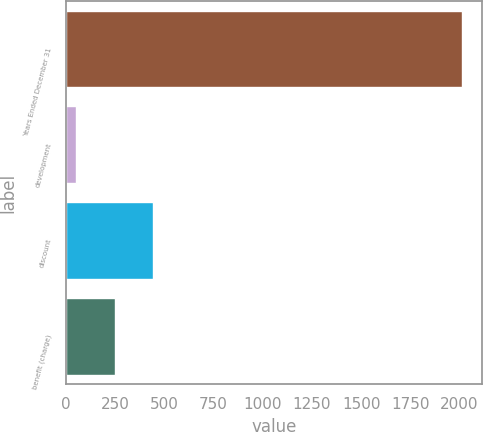Convert chart to OTSL. <chart><loc_0><loc_0><loc_500><loc_500><bar_chart><fcel>Years Ended December 31<fcel>development<fcel>discount<fcel>benefit (charge)<nl><fcel>2014<fcel>52<fcel>444.4<fcel>248.2<nl></chart> 